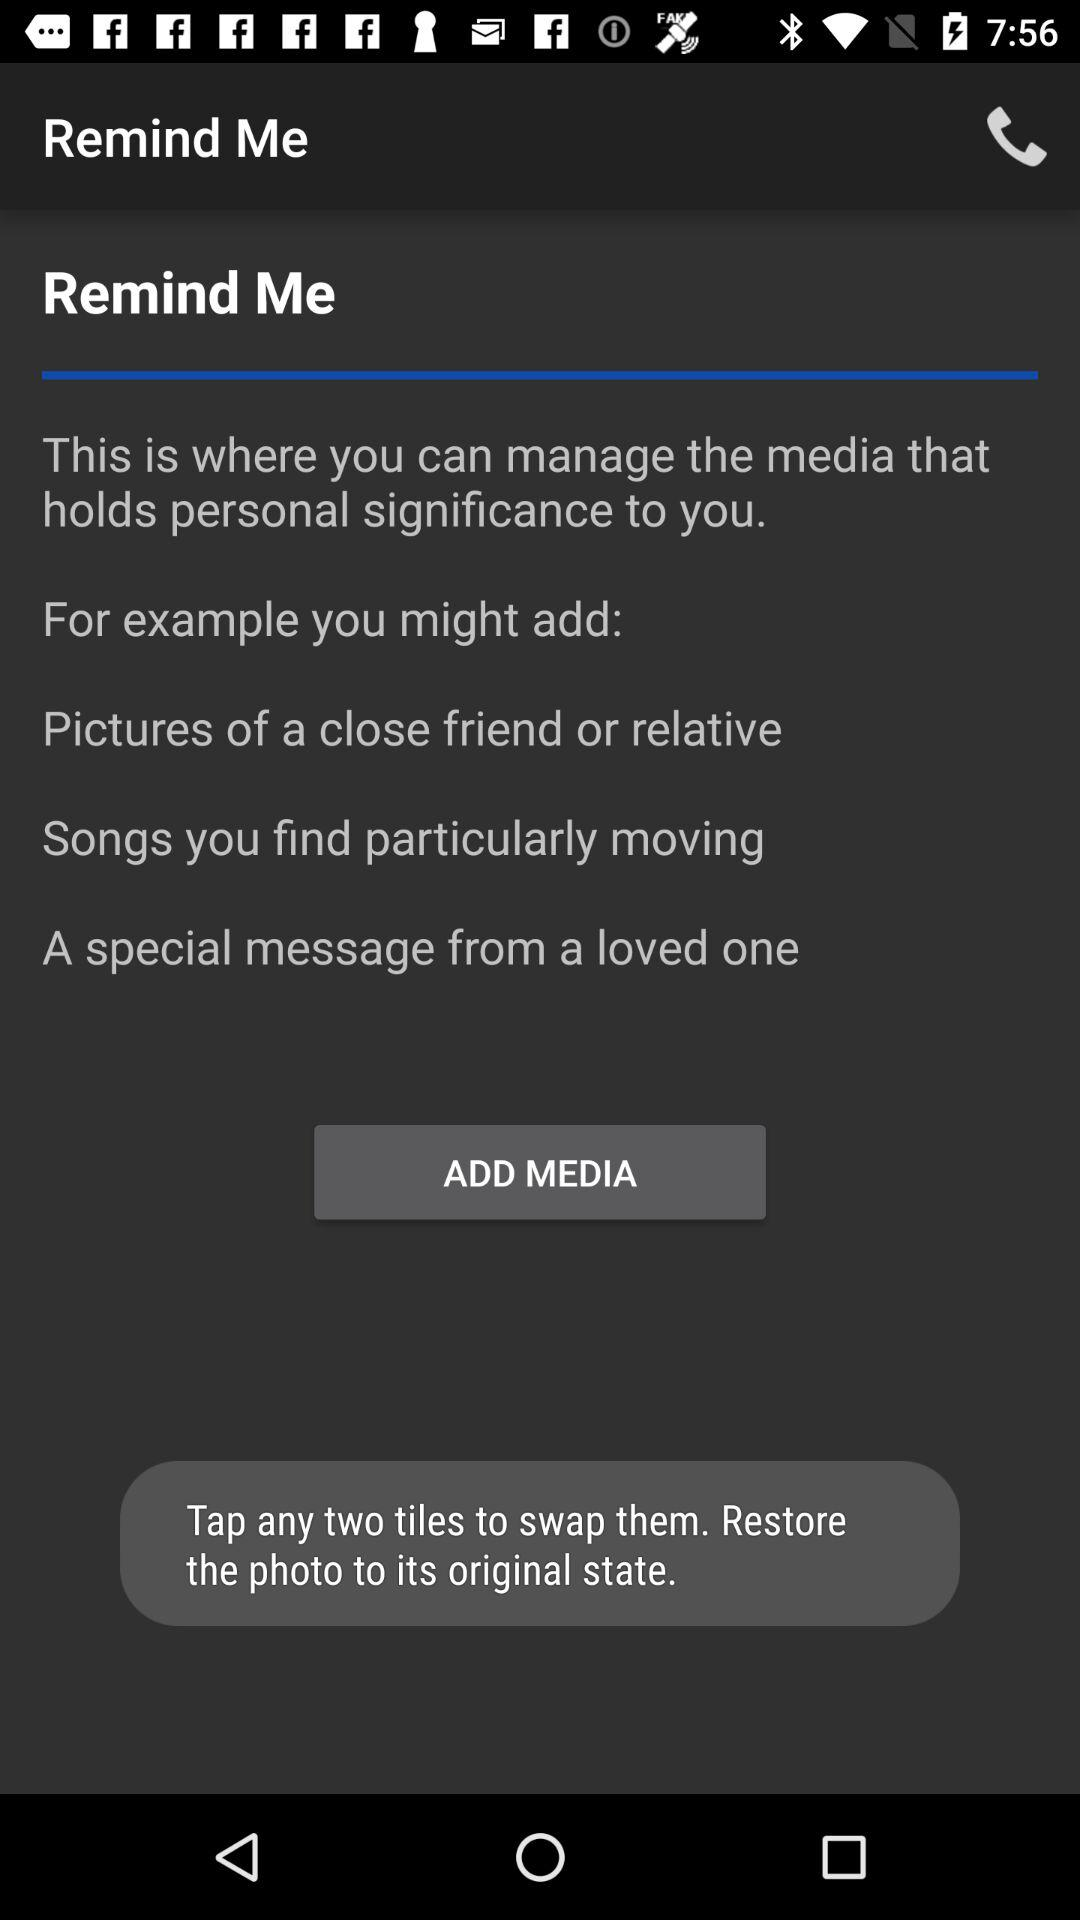How many examples are there of media that holds personal significance to me?
Answer the question using a single word or phrase. 3 